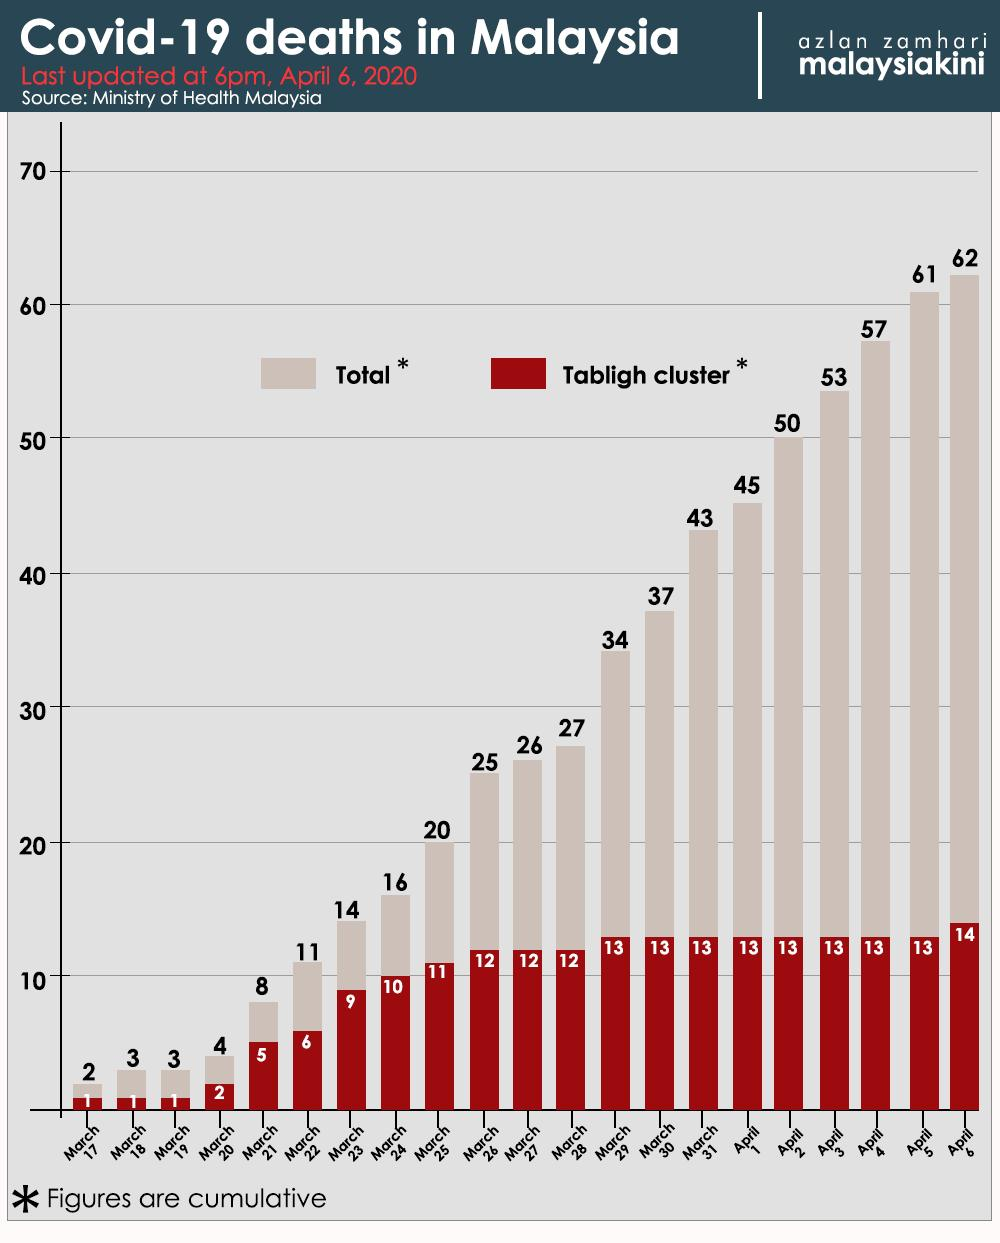List a handful of essential elements in this visual. As of March 25, 2020, the total number of COVID-19 deaths in Malaysia is 20. As of April 5, 2020, the number of COVID-19 deaths in the Tabligh cluster in Malaysia was 13. As of April 2, 2020, the total number of COVID-19 deaths in Malaysia was 50. As of April 6, 2020, the number of COVID-19 deaths in the Tabligh cluster in Malaysia was 14. 